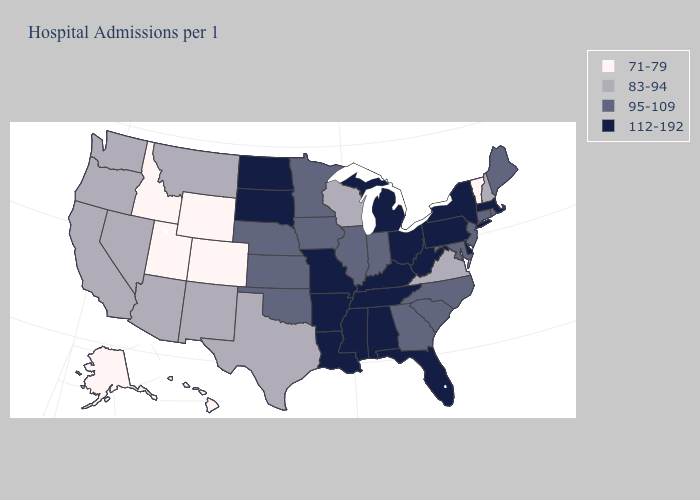Does Idaho have the lowest value in the USA?
Concise answer only. Yes. What is the highest value in the USA?
Answer briefly. 112-192. Name the states that have a value in the range 112-192?
Write a very short answer. Alabama, Arkansas, Delaware, Florida, Kentucky, Louisiana, Massachusetts, Michigan, Mississippi, Missouri, New York, North Dakota, Ohio, Pennsylvania, South Dakota, Tennessee, West Virginia. What is the value of Georgia?
Keep it brief. 95-109. Name the states that have a value in the range 112-192?
Keep it brief. Alabama, Arkansas, Delaware, Florida, Kentucky, Louisiana, Massachusetts, Michigan, Mississippi, Missouri, New York, North Dakota, Ohio, Pennsylvania, South Dakota, Tennessee, West Virginia. What is the value of Idaho?
Answer briefly. 71-79. What is the lowest value in the MidWest?
Answer briefly. 83-94. Among the states that border Iowa , which have the highest value?
Be succinct. Missouri, South Dakota. What is the value of Louisiana?
Short answer required. 112-192. Which states have the lowest value in the MidWest?
Be succinct. Wisconsin. Does the first symbol in the legend represent the smallest category?
Write a very short answer. Yes. What is the value of Mississippi?
Keep it brief. 112-192. Name the states that have a value in the range 112-192?
Short answer required. Alabama, Arkansas, Delaware, Florida, Kentucky, Louisiana, Massachusetts, Michigan, Mississippi, Missouri, New York, North Dakota, Ohio, Pennsylvania, South Dakota, Tennessee, West Virginia. What is the highest value in states that border Massachusetts?
Give a very brief answer. 112-192. What is the value of Georgia?
Answer briefly. 95-109. 